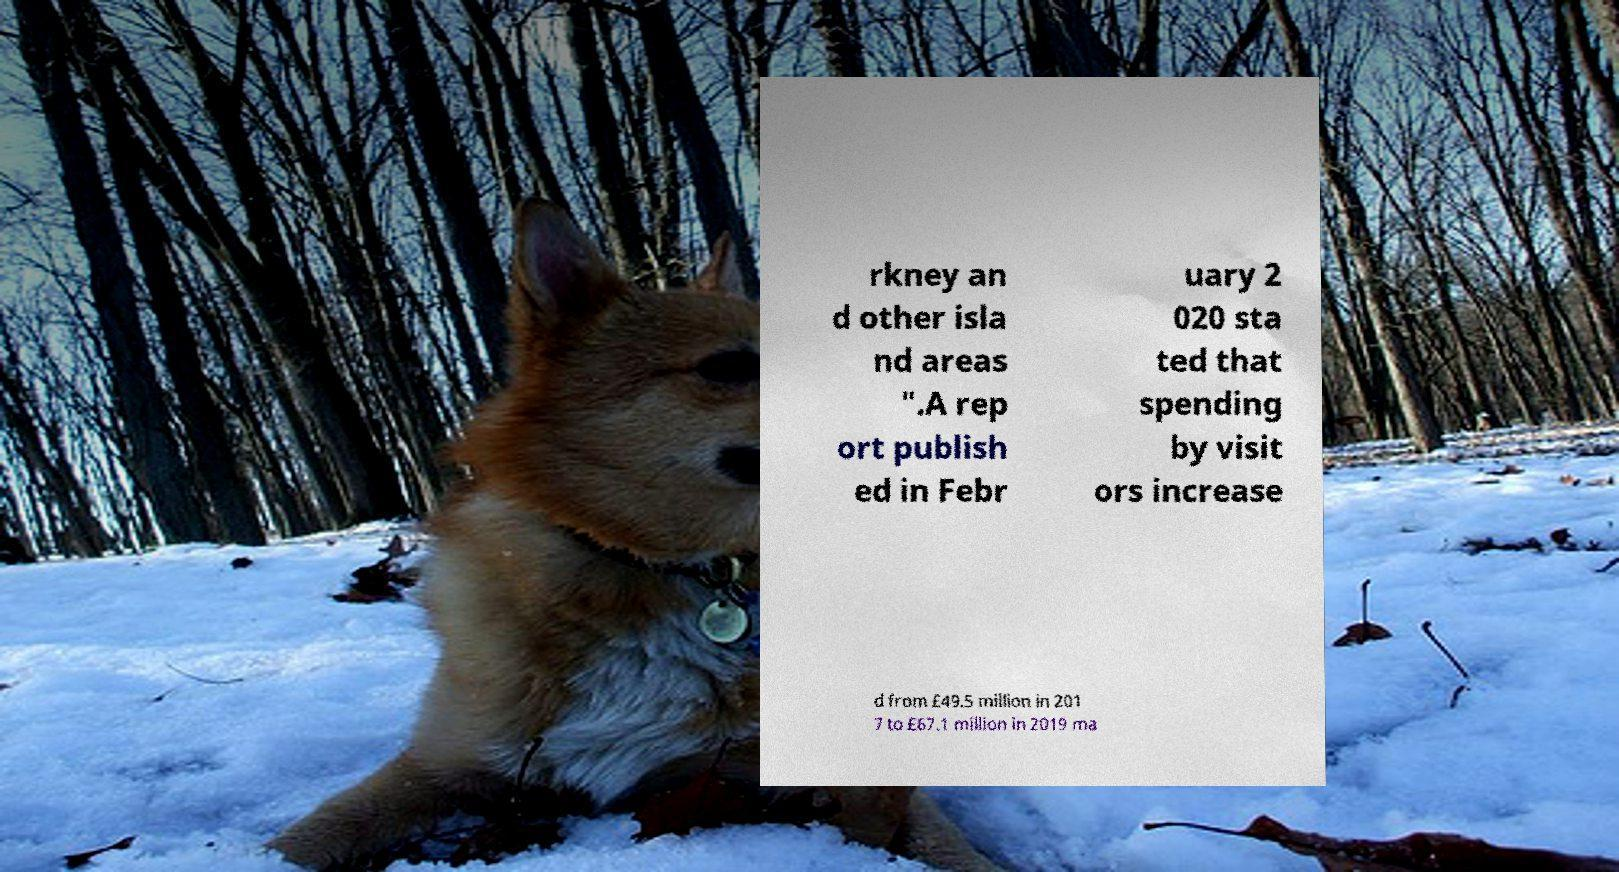I need the written content from this picture converted into text. Can you do that? rkney an d other isla nd areas ".A rep ort publish ed in Febr uary 2 020 sta ted that spending by visit ors increase d from £49.5 million in 201 7 to £67.1 million in 2019 ma 